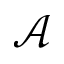Convert formula to latex. <formula><loc_0><loc_0><loc_500><loc_500>\mathcal { A }</formula> 